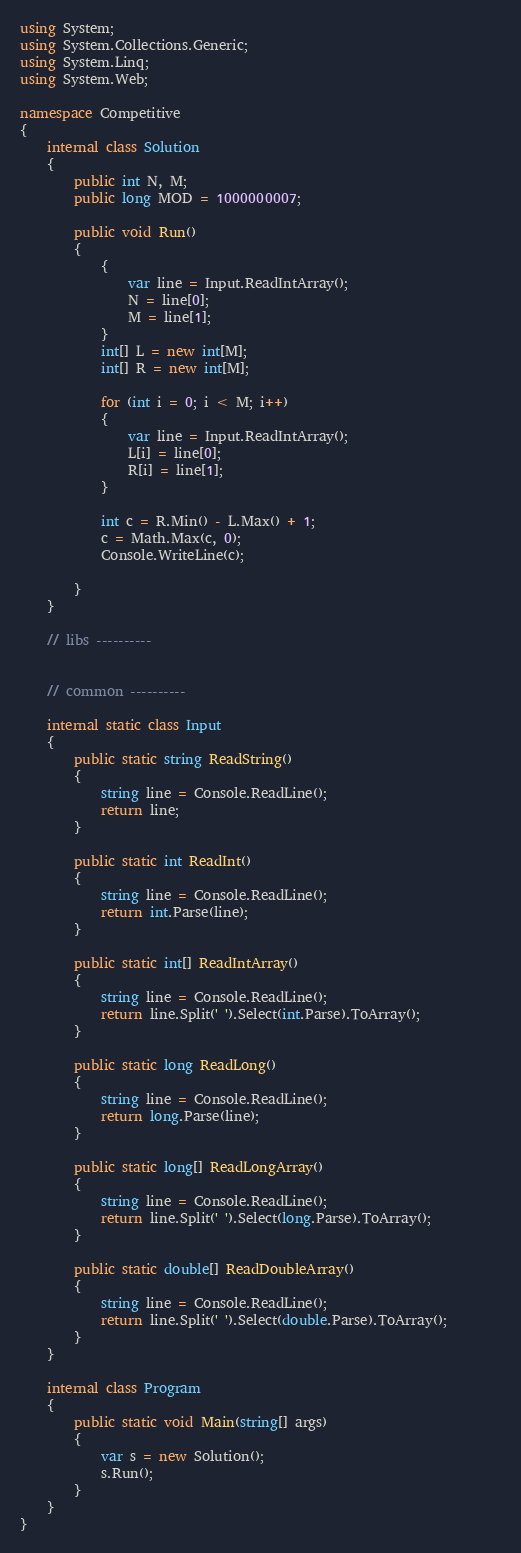Convert code to text. <code><loc_0><loc_0><loc_500><loc_500><_C#_>using System;
using System.Collections.Generic;
using System.Linq;
using System.Web;

namespace Competitive
{
    internal class Solution
    {
        public int N, M;
        public long MOD = 1000000007;

        public void Run()
        {
            {
                var line = Input.ReadIntArray();
                N = line[0];
                M = line[1];
            }
            int[] L = new int[M];
            int[] R = new int[M];

            for (int i = 0; i < M; i++)
            {
                var line = Input.ReadIntArray();
                L[i] = line[0];
                R[i] = line[1];
            }

            int c = R.Min() - L.Max() + 1;
            c = Math.Max(c, 0);
            Console.WriteLine(c);

        }
    }

    // libs ----------
    

    // common ----------

    internal static class Input
    {
        public static string ReadString()
        {
            string line = Console.ReadLine();
            return line;
        }

        public static int ReadInt()
        {
            string line = Console.ReadLine();
            return int.Parse(line);
        }

        public static int[] ReadIntArray()
        {
            string line = Console.ReadLine();
            return line.Split(' ').Select(int.Parse).ToArray();            
        }

        public static long ReadLong()
        {
            string line = Console.ReadLine();
            return long.Parse(line);
        }

        public static long[] ReadLongArray()
        {
            string line = Console.ReadLine();
            return line.Split(' ').Select(long.Parse).ToArray();
        }

        public static double[] ReadDoubleArray()
        {
            string line = Console.ReadLine();
            return line.Split(' ').Select(double.Parse).ToArray();
        }
    }
    
    internal class Program
    {
        public static void Main(string[] args)
        {
            var s = new Solution();
            s.Run();
        }
    }
}</code> 